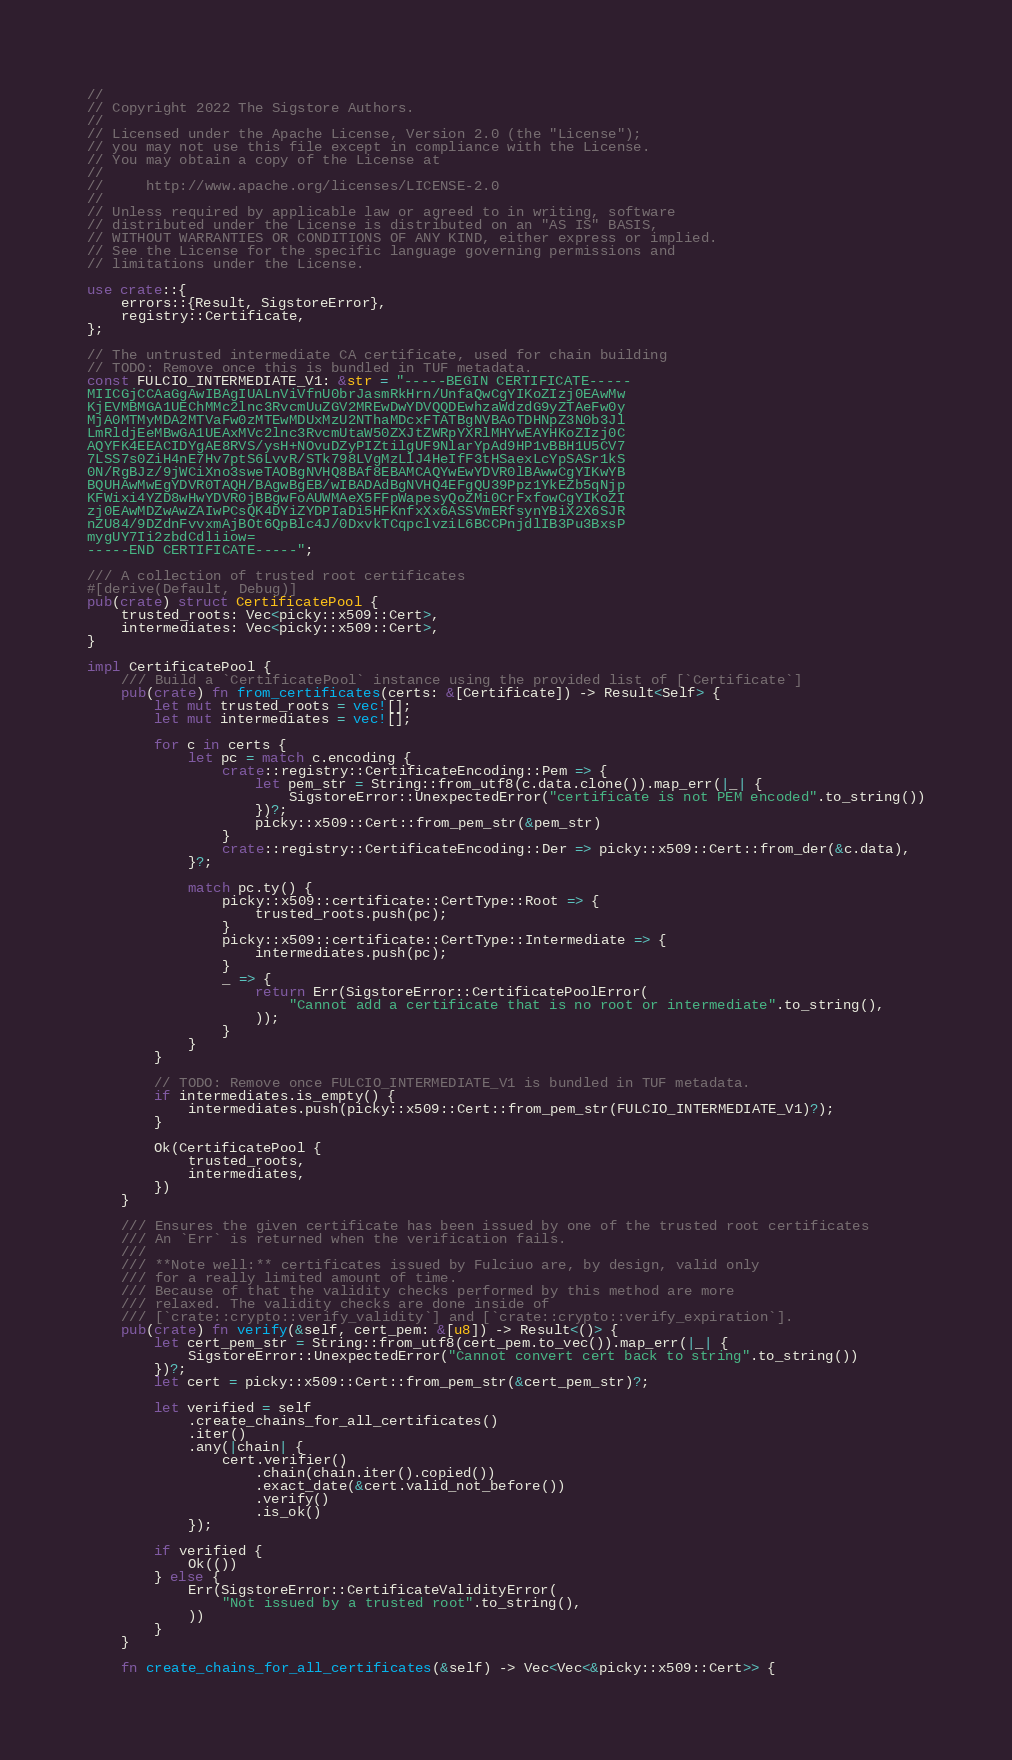Convert code to text. <code><loc_0><loc_0><loc_500><loc_500><_Rust_>//
// Copyright 2022 The Sigstore Authors.
//
// Licensed under the Apache License, Version 2.0 (the "License");
// you may not use this file except in compliance with the License.
// You may obtain a copy of the License at
//
//     http://www.apache.org/licenses/LICENSE-2.0
//
// Unless required by applicable law or agreed to in writing, software
// distributed under the License is distributed on an "AS IS" BASIS,
// WITHOUT WARRANTIES OR CONDITIONS OF ANY KIND, either express or implied.
// See the License for the specific language governing permissions and
// limitations under the License.

use crate::{
    errors::{Result, SigstoreError},
    registry::Certificate,
};

// The untrusted intermediate CA certificate, used for chain building
// TODO: Remove once this is bundled in TUF metadata.
const FULCIO_INTERMEDIATE_V1: &str = "-----BEGIN CERTIFICATE-----
MIICGjCCAaGgAwIBAgIUALnViVfnU0brJasmRkHrn/UnfaQwCgYIKoZIzj0EAwMw
KjEVMBMGA1UEChMMc2lnc3RvcmUuZGV2MREwDwYDVQQDEwhzaWdzdG9yZTAeFw0y
MjA0MTMyMDA2MTVaFw0zMTEwMDUxMzU2NThaMDcxFTATBgNVBAoTDHNpZ3N0b3Jl
LmRldjEeMBwGA1UEAxMVc2lnc3RvcmUtaW50ZXJtZWRpYXRlMHYwEAYHKoZIzj0C
AQYFK4EEACIDYgAE8RVS/ysH+NOvuDZyPIZtilgUF9NlarYpAd9HP1vBBH1U5CV7
7LSS7s0ZiH4nE7Hv7ptS6LvvR/STk798LVgMzLlJ4HeIfF3tHSaexLcYpSASr1kS
0N/RgBJz/9jWCiXno3sweTAOBgNVHQ8BAf8EBAMCAQYwEwYDVR0lBAwwCgYIKwYB
BQUHAwMwEgYDVR0TAQH/BAgwBgEB/wIBADAdBgNVHQ4EFgQU39Ppz1YkEZb5qNjp
KFWixi4YZD8wHwYDVR0jBBgwFoAUWMAeX5FFpWapesyQoZMi0CrFxfowCgYIKoZI
zj0EAwMDZwAwZAIwPCsQK4DYiZYDPIaDi5HFKnfxXx6ASSVmERfsynYBiX2X6SJR
nZU84/9DZdnFvvxmAjBOt6QpBlc4J/0DxvkTCqpclvziL6BCCPnjdlIB3Pu3BxsP
mygUY7Ii2zbdCdliiow=
-----END CERTIFICATE-----";

/// A collection of trusted root certificates
#[derive(Default, Debug)]
pub(crate) struct CertificatePool {
    trusted_roots: Vec<picky::x509::Cert>,
    intermediates: Vec<picky::x509::Cert>,
}

impl CertificatePool {
    /// Build a `CertificatePool` instance using the provided list of [`Certificate`]
    pub(crate) fn from_certificates(certs: &[Certificate]) -> Result<Self> {
        let mut trusted_roots = vec![];
        let mut intermediates = vec![];

        for c in certs {
            let pc = match c.encoding {
                crate::registry::CertificateEncoding::Pem => {
                    let pem_str = String::from_utf8(c.data.clone()).map_err(|_| {
                        SigstoreError::UnexpectedError("certificate is not PEM encoded".to_string())
                    })?;
                    picky::x509::Cert::from_pem_str(&pem_str)
                }
                crate::registry::CertificateEncoding::Der => picky::x509::Cert::from_der(&c.data),
            }?;

            match pc.ty() {
                picky::x509::certificate::CertType::Root => {
                    trusted_roots.push(pc);
                }
                picky::x509::certificate::CertType::Intermediate => {
                    intermediates.push(pc);
                }
                _ => {
                    return Err(SigstoreError::CertificatePoolError(
                        "Cannot add a certificate that is no root or intermediate".to_string(),
                    ));
                }
            }
        }

        // TODO: Remove once FULCIO_INTERMEDIATE_V1 is bundled in TUF metadata.
        if intermediates.is_empty() {
            intermediates.push(picky::x509::Cert::from_pem_str(FULCIO_INTERMEDIATE_V1)?);
        }

        Ok(CertificatePool {
            trusted_roots,
            intermediates,
        })
    }

    /// Ensures the given certificate has been issued by one of the trusted root certificates
    /// An `Err` is returned when the verification fails.
    ///
    /// **Note well:** certificates issued by Fulciuo are, by design, valid only
    /// for a really limited amount of time.
    /// Because of that the validity checks performed by this method are more
    /// relaxed. The validity checks are done inside of
    /// [`crate::crypto::verify_validity`] and [`crate::crypto::verify_expiration`].
    pub(crate) fn verify(&self, cert_pem: &[u8]) -> Result<()> {
        let cert_pem_str = String::from_utf8(cert_pem.to_vec()).map_err(|_| {
            SigstoreError::UnexpectedError("Cannot convert cert back to string".to_string())
        })?;
        let cert = picky::x509::Cert::from_pem_str(&cert_pem_str)?;

        let verified = self
            .create_chains_for_all_certificates()
            .iter()
            .any(|chain| {
                cert.verifier()
                    .chain(chain.iter().copied())
                    .exact_date(&cert.valid_not_before())
                    .verify()
                    .is_ok()
            });

        if verified {
            Ok(())
        } else {
            Err(SigstoreError::CertificateValidityError(
                "Not issued by a trusted root".to_string(),
            ))
        }
    }

    fn create_chains_for_all_certificates(&self) -> Vec<Vec<&picky::x509::Cert>> {</code> 